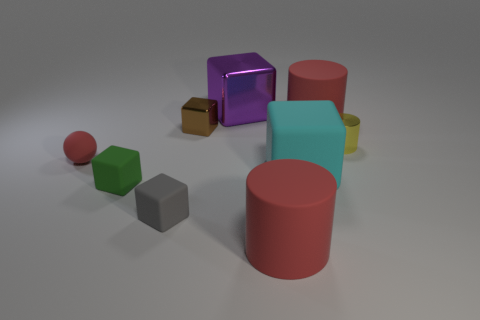How many objects are either large things in front of the purple thing or big red matte things to the right of the big cyan object?
Ensure brevity in your answer.  3. Does the green rubber block have the same size as the cyan matte cube?
Your answer should be very brief. No. There is a tiny matte thing that is on the right side of the small green matte object; does it have the same shape as the cyan rubber thing right of the red rubber sphere?
Your answer should be compact. Yes. How big is the red ball?
Your answer should be compact. Small. What is the material of the cylinder right of the large red thing behind the green rubber thing left of the small brown metallic block?
Your answer should be compact. Metal. How many other objects are the same color as the sphere?
Provide a succinct answer. 2. How many gray objects are small shiny cubes or small objects?
Your response must be concise. 1. There is a large block that is in front of the purple shiny thing; what is its material?
Provide a succinct answer. Rubber. Are the big red thing that is in front of the small rubber ball and the cyan thing made of the same material?
Offer a very short reply. Yes. The yellow object is what shape?
Make the answer very short. Cylinder. 